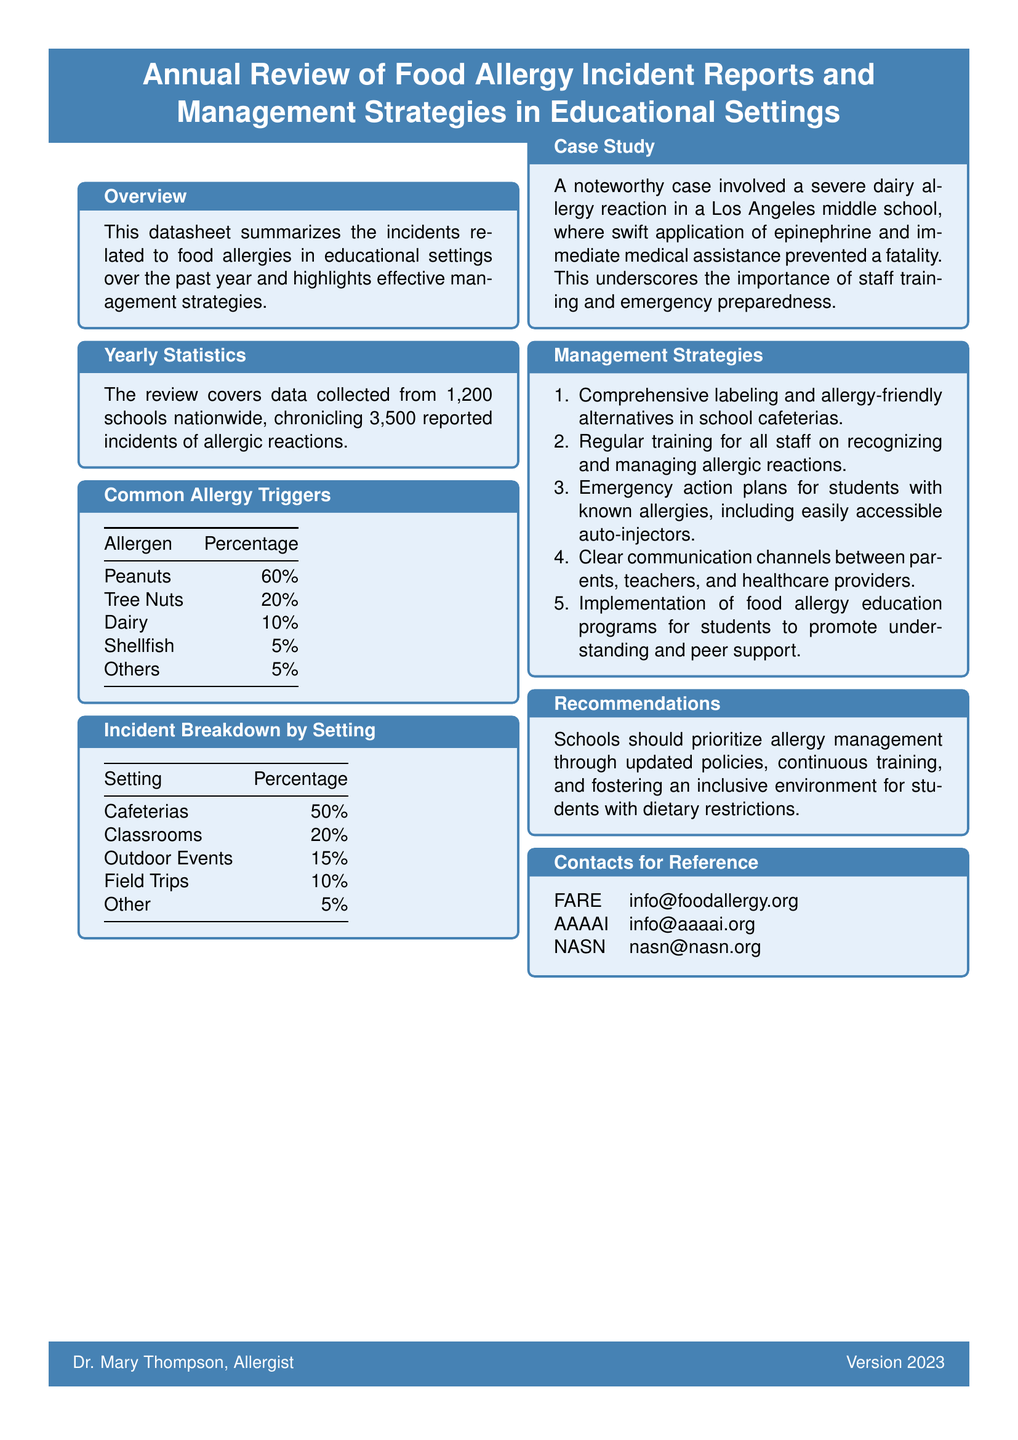What is the title of the document? The title is provided in the header of the document, specifically stating the annual review subject.
Answer: Annual Review of Food Allergy Incident Reports and Management Strategies in Educational Settings How many schools are covered in the review? The total number of schools being reviewed is mentioned in the statistics section.
Answer: 1,200 schools What percentage of allergic reactions are triggered by peanuts? The specific percentage attributed to peanuts is listed in the common allergy triggers table.
Answer: 60% What setting has the highest percentage of allergic incidents? The setting with the highest recorded incidents is noted in the incident breakdown by setting section.
Answer: Cafeterias What management strategy involves training staff? The management strategies cover various aspects, including staff training, which is clearly stated.
Answer: Regular training for all staff on recognizing and managing allergic reactions Which allergen had the lowest percentage reported in incidents? The allergens are listed by percentage, with the lowest percentage identified in the common allergy triggers table.
Answer: Shellfish 